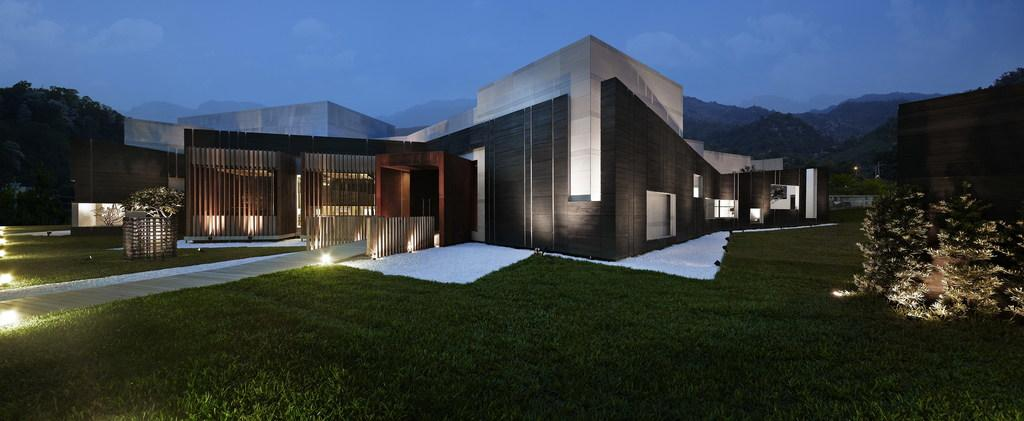What type of structure is present in the image? There is a building in the image. What is located in front of the building? There are plants and grass in front of the building. Can you describe the lighting in the image? There are lights visible in the image. What can be seen in the background of the image? There are many trees and mountains in the background, as well as the sky. What type of account is being discussed in the image? There is no account being discussed in the image; it features a building, plants, grass, lights, trees, mountains, and the sky. Can you tell me how many bulbs are present in the image? There is no mention of bulbs in the image; it features a building, plants, grass, lights, trees, mountains, and the sky. 